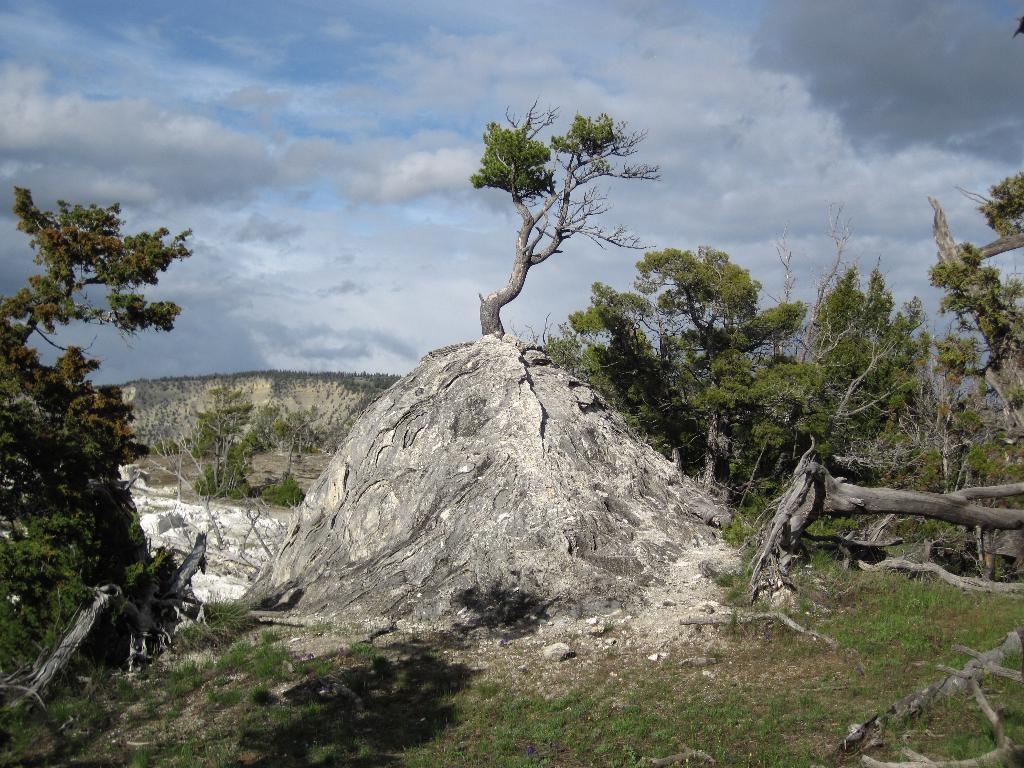What type of surface is visible in the image? There is a grass surface in the image. What other natural elements can be seen in the image? There are plants and a rock hill with a tree on it in the image. What can be seen in the distance in the image? There are hills visible in the background of the image. What is visible above the hills in the image? The sky is visible in the background of the image, and clouds are present in the sky. What degree of difficulty is the dress designed for in the image? There is no dress present in the image, so it is not possible to determine the degree of difficulty of any dress. 